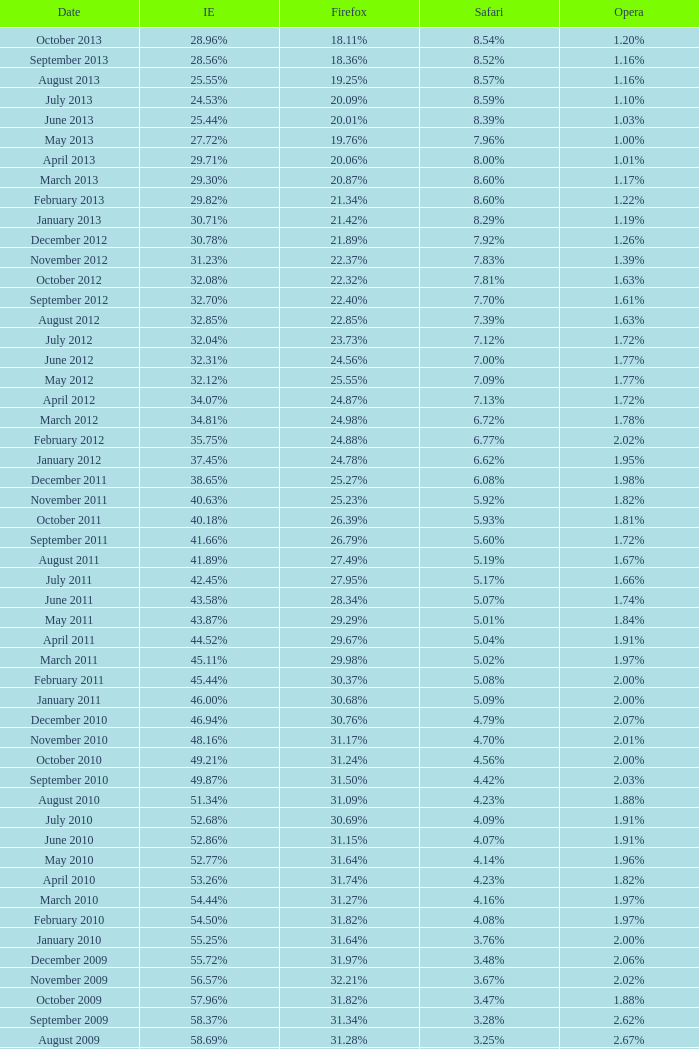What percentage of browsers were using Safari during the period in which 31.27% were using Firefox? 4.16%. 